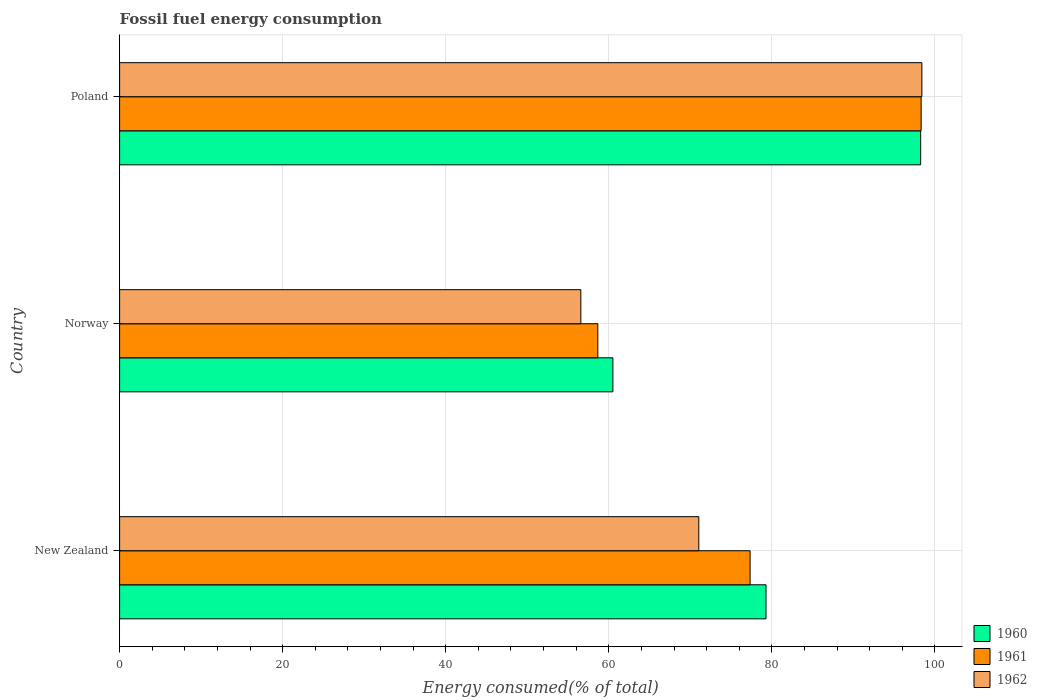How many different coloured bars are there?
Your answer should be very brief. 3. Are the number of bars on each tick of the Y-axis equal?
Offer a terse response. Yes. How many bars are there on the 2nd tick from the top?
Your answer should be compact. 3. What is the label of the 3rd group of bars from the top?
Give a very brief answer. New Zealand. What is the percentage of energy consumed in 1960 in Norway?
Provide a short and direct response. 60.5. Across all countries, what is the maximum percentage of energy consumed in 1962?
Your answer should be very brief. 98.4. Across all countries, what is the minimum percentage of energy consumed in 1962?
Your response must be concise. 56.57. In which country was the percentage of energy consumed in 1962 maximum?
Your response must be concise. Poland. In which country was the percentage of energy consumed in 1960 minimum?
Keep it short and to the point. Norway. What is the total percentage of energy consumed in 1962 in the graph?
Offer a terse response. 226. What is the difference between the percentage of energy consumed in 1962 in New Zealand and that in Poland?
Keep it short and to the point. -27.36. What is the difference between the percentage of energy consumed in 1961 in New Zealand and the percentage of energy consumed in 1960 in Norway?
Make the answer very short. 16.83. What is the average percentage of energy consumed in 1961 per country?
Keep it short and to the point. 78.09. What is the difference between the percentage of energy consumed in 1962 and percentage of energy consumed in 1960 in New Zealand?
Provide a short and direct response. -8.24. In how many countries, is the percentage of energy consumed in 1961 greater than 56 %?
Your answer should be very brief. 3. What is the ratio of the percentage of energy consumed in 1961 in Norway to that in Poland?
Ensure brevity in your answer.  0.6. Is the percentage of energy consumed in 1960 in Norway less than that in Poland?
Offer a very short reply. Yes. Is the difference between the percentage of energy consumed in 1962 in New Zealand and Poland greater than the difference between the percentage of energy consumed in 1960 in New Zealand and Poland?
Make the answer very short. No. What is the difference between the highest and the second highest percentage of energy consumed in 1962?
Provide a succinct answer. 27.36. What is the difference between the highest and the lowest percentage of energy consumed in 1962?
Provide a succinct answer. 41.83. Is the sum of the percentage of energy consumed in 1960 in Norway and Poland greater than the maximum percentage of energy consumed in 1961 across all countries?
Your response must be concise. Yes. Is it the case that in every country, the sum of the percentage of energy consumed in 1960 and percentage of energy consumed in 1961 is greater than the percentage of energy consumed in 1962?
Provide a succinct answer. Yes. Are all the bars in the graph horizontal?
Keep it short and to the point. Yes. How many countries are there in the graph?
Keep it short and to the point. 3. What is the difference between two consecutive major ticks on the X-axis?
Your response must be concise. 20. Are the values on the major ticks of X-axis written in scientific E-notation?
Give a very brief answer. No. Does the graph contain any zero values?
Offer a very short reply. No. Where does the legend appear in the graph?
Make the answer very short. Bottom right. What is the title of the graph?
Make the answer very short. Fossil fuel energy consumption. What is the label or title of the X-axis?
Your response must be concise. Energy consumed(% of total). What is the label or title of the Y-axis?
Your response must be concise. Country. What is the Energy consumed(% of total) in 1960 in New Zealand?
Make the answer very short. 79.28. What is the Energy consumed(% of total) in 1961 in New Zealand?
Give a very brief answer. 77.33. What is the Energy consumed(% of total) in 1962 in New Zealand?
Give a very brief answer. 71.04. What is the Energy consumed(% of total) of 1960 in Norway?
Offer a terse response. 60.5. What is the Energy consumed(% of total) of 1961 in Norway?
Make the answer very short. 58.65. What is the Energy consumed(% of total) of 1962 in Norway?
Make the answer very short. 56.57. What is the Energy consumed(% of total) in 1960 in Poland?
Make the answer very short. 98.25. What is the Energy consumed(% of total) in 1961 in Poland?
Provide a short and direct response. 98.3. What is the Energy consumed(% of total) of 1962 in Poland?
Ensure brevity in your answer.  98.4. Across all countries, what is the maximum Energy consumed(% of total) of 1960?
Your answer should be very brief. 98.25. Across all countries, what is the maximum Energy consumed(% of total) in 1961?
Your response must be concise. 98.3. Across all countries, what is the maximum Energy consumed(% of total) of 1962?
Make the answer very short. 98.4. Across all countries, what is the minimum Energy consumed(% of total) in 1960?
Keep it short and to the point. 60.5. Across all countries, what is the minimum Energy consumed(% of total) of 1961?
Your answer should be compact. 58.65. Across all countries, what is the minimum Energy consumed(% of total) in 1962?
Your answer should be compact. 56.57. What is the total Energy consumed(% of total) in 1960 in the graph?
Provide a short and direct response. 238.02. What is the total Energy consumed(% of total) in 1961 in the graph?
Your answer should be compact. 234.28. What is the total Energy consumed(% of total) of 1962 in the graph?
Give a very brief answer. 226. What is the difference between the Energy consumed(% of total) in 1960 in New Zealand and that in Norway?
Keep it short and to the point. 18.78. What is the difference between the Energy consumed(% of total) of 1961 in New Zealand and that in Norway?
Give a very brief answer. 18.68. What is the difference between the Energy consumed(% of total) in 1962 in New Zealand and that in Norway?
Provide a succinct answer. 14.47. What is the difference between the Energy consumed(% of total) of 1960 in New Zealand and that in Poland?
Offer a terse response. -18.97. What is the difference between the Energy consumed(% of total) in 1961 in New Zealand and that in Poland?
Ensure brevity in your answer.  -20.98. What is the difference between the Energy consumed(% of total) in 1962 in New Zealand and that in Poland?
Your answer should be very brief. -27.36. What is the difference between the Energy consumed(% of total) in 1960 in Norway and that in Poland?
Provide a short and direct response. -37.75. What is the difference between the Energy consumed(% of total) in 1961 in Norway and that in Poland?
Keep it short and to the point. -39.65. What is the difference between the Energy consumed(% of total) in 1962 in Norway and that in Poland?
Provide a short and direct response. -41.83. What is the difference between the Energy consumed(% of total) in 1960 in New Zealand and the Energy consumed(% of total) in 1961 in Norway?
Offer a very short reply. 20.63. What is the difference between the Energy consumed(% of total) in 1960 in New Zealand and the Energy consumed(% of total) in 1962 in Norway?
Offer a very short reply. 22.71. What is the difference between the Energy consumed(% of total) of 1961 in New Zealand and the Energy consumed(% of total) of 1962 in Norway?
Keep it short and to the point. 20.76. What is the difference between the Energy consumed(% of total) of 1960 in New Zealand and the Energy consumed(% of total) of 1961 in Poland?
Offer a very short reply. -19.02. What is the difference between the Energy consumed(% of total) in 1960 in New Zealand and the Energy consumed(% of total) in 1962 in Poland?
Offer a very short reply. -19.12. What is the difference between the Energy consumed(% of total) in 1961 in New Zealand and the Energy consumed(% of total) in 1962 in Poland?
Your response must be concise. -21.07. What is the difference between the Energy consumed(% of total) of 1960 in Norway and the Energy consumed(% of total) of 1961 in Poland?
Keep it short and to the point. -37.81. What is the difference between the Energy consumed(% of total) in 1960 in Norway and the Energy consumed(% of total) in 1962 in Poland?
Your answer should be compact. -37.9. What is the difference between the Energy consumed(% of total) of 1961 in Norway and the Energy consumed(% of total) of 1962 in Poland?
Your answer should be very brief. -39.74. What is the average Energy consumed(% of total) in 1960 per country?
Offer a very short reply. 79.34. What is the average Energy consumed(% of total) of 1961 per country?
Keep it short and to the point. 78.09. What is the average Energy consumed(% of total) of 1962 per country?
Offer a very short reply. 75.33. What is the difference between the Energy consumed(% of total) in 1960 and Energy consumed(% of total) in 1961 in New Zealand?
Your answer should be compact. 1.95. What is the difference between the Energy consumed(% of total) of 1960 and Energy consumed(% of total) of 1962 in New Zealand?
Provide a succinct answer. 8.24. What is the difference between the Energy consumed(% of total) of 1961 and Energy consumed(% of total) of 1962 in New Zealand?
Your answer should be compact. 6.29. What is the difference between the Energy consumed(% of total) of 1960 and Energy consumed(% of total) of 1961 in Norway?
Offer a very short reply. 1.85. What is the difference between the Energy consumed(% of total) in 1960 and Energy consumed(% of total) in 1962 in Norway?
Provide a short and direct response. 3.93. What is the difference between the Energy consumed(% of total) in 1961 and Energy consumed(% of total) in 1962 in Norway?
Your response must be concise. 2.08. What is the difference between the Energy consumed(% of total) in 1960 and Energy consumed(% of total) in 1961 in Poland?
Offer a terse response. -0.06. What is the difference between the Energy consumed(% of total) of 1960 and Energy consumed(% of total) of 1962 in Poland?
Provide a succinct answer. -0.15. What is the difference between the Energy consumed(% of total) in 1961 and Energy consumed(% of total) in 1962 in Poland?
Offer a terse response. -0.09. What is the ratio of the Energy consumed(% of total) in 1960 in New Zealand to that in Norway?
Your answer should be compact. 1.31. What is the ratio of the Energy consumed(% of total) of 1961 in New Zealand to that in Norway?
Ensure brevity in your answer.  1.32. What is the ratio of the Energy consumed(% of total) of 1962 in New Zealand to that in Norway?
Make the answer very short. 1.26. What is the ratio of the Energy consumed(% of total) of 1960 in New Zealand to that in Poland?
Ensure brevity in your answer.  0.81. What is the ratio of the Energy consumed(% of total) in 1961 in New Zealand to that in Poland?
Your answer should be compact. 0.79. What is the ratio of the Energy consumed(% of total) of 1962 in New Zealand to that in Poland?
Your response must be concise. 0.72. What is the ratio of the Energy consumed(% of total) of 1960 in Norway to that in Poland?
Your response must be concise. 0.62. What is the ratio of the Energy consumed(% of total) in 1961 in Norway to that in Poland?
Provide a short and direct response. 0.6. What is the ratio of the Energy consumed(% of total) of 1962 in Norway to that in Poland?
Offer a very short reply. 0.57. What is the difference between the highest and the second highest Energy consumed(% of total) of 1960?
Offer a very short reply. 18.97. What is the difference between the highest and the second highest Energy consumed(% of total) of 1961?
Provide a short and direct response. 20.98. What is the difference between the highest and the second highest Energy consumed(% of total) in 1962?
Offer a terse response. 27.36. What is the difference between the highest and the lowest Energy consumed(% of total) in 1960?
Provide a short and direct response. 37.75. What is the difference between the highest and the lowest Energy consumed(% of total) in 1961?
Offer a very short reply. 39.65. What is the difference between the highest and the lowest Energy consumed(% of total) of 1962?
Your answer should be very brief. 41.83. 